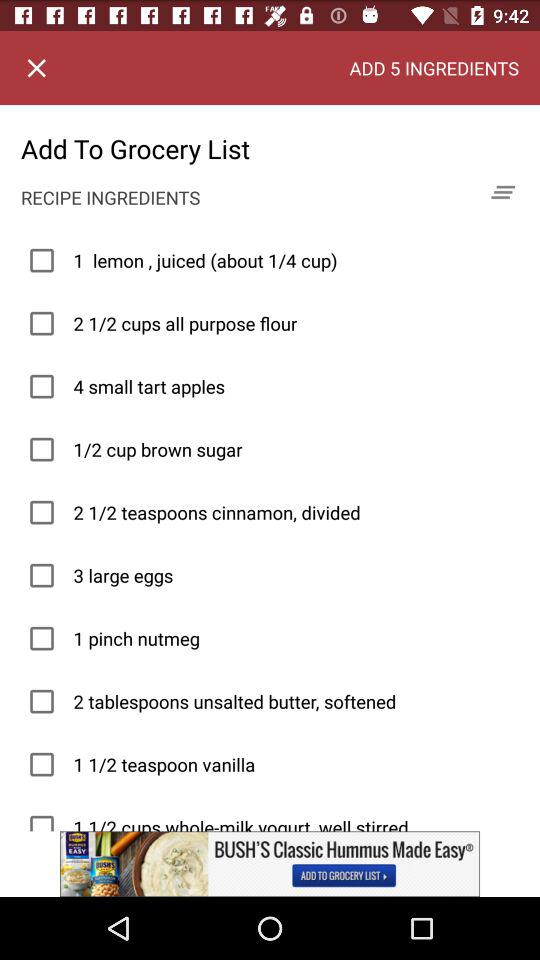What are the names of the recipe ingredients shown on the screen? The names of the recipe ingredients shown on the screen are "1 lemon, juiced (about 1/4 cup)", "2 1/2 cups all purpose flour", "4 small tart apples", "1/2 cup brown sugar", "2 1/2 teaspoons cinnamon, divided", "3 large eggs", "1 pinch nutmeg", "2 tablespoons unsalted butter, softened", "1 1/2 teaspoon vanilla" and "1 1/2 cups whole-milk yogurt well stirred". 